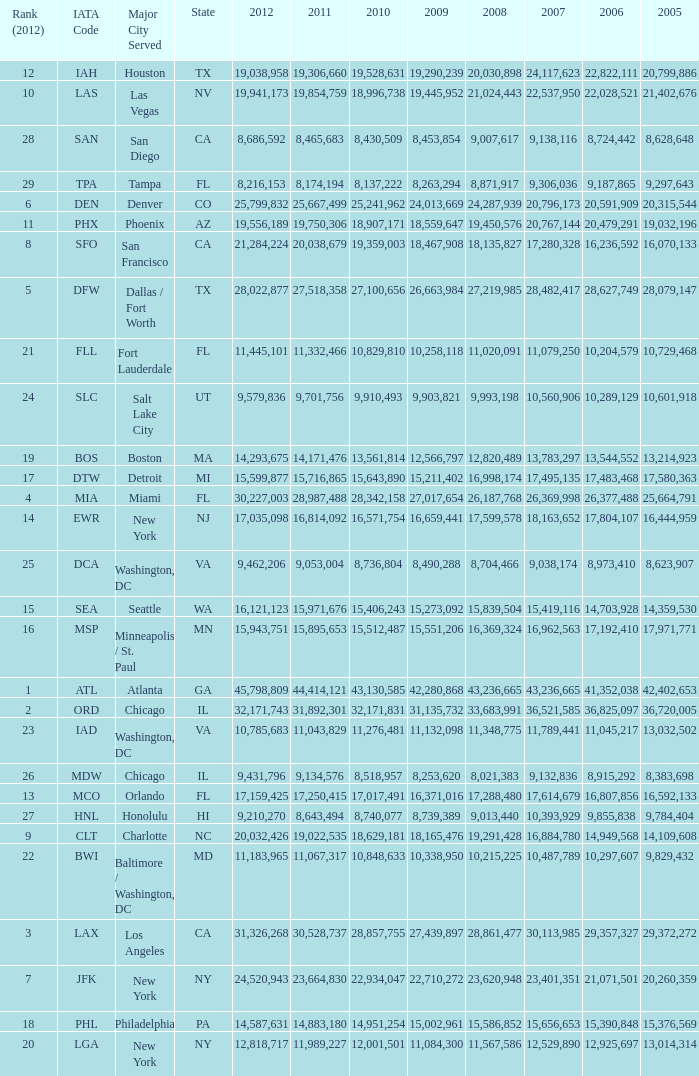What is the greatest 2010 for Miami, Fl? 28342158.0. 